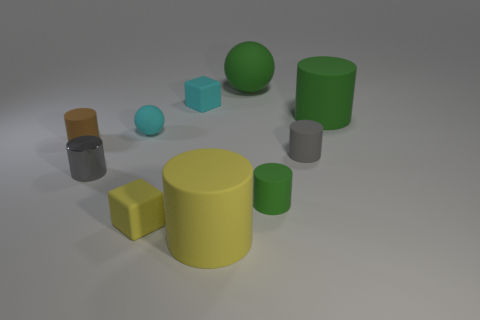There is another cylinder that is the same color as the small metallic cylinder; what size is it?
Ensure brevity in your answer.  Small. What is the shape of the small object that is the same color as the metal cylinder?
Offer a terse response. Cylinder. Is there a block?
Keep it short and to the point. Yes. Does the yellow thing that is behind the yellow rubber cylinder have the same shape as the matte object that is left of the tiny cyan matte sphere?
Your response must be concise. No. What number of big things are gray cylinders or cyan matte cubes?
Your response must be concise. 0. The small green thing that is made of the same material as the cyan block is what shape?
Keep it short and to the point. Cylinder. Do the small gray shiny object and the brown thing have the same shape?
Provide a short and direct response. Yes. What is the color of the tiny ball?
Your answer should be very brief. Cyan. How many things are either big metallic things or balls?
Give a very brief answer. 2. Are there any other things that have the same material as the tiny cyan sphere?
Your answer should be very brief. Yes. 